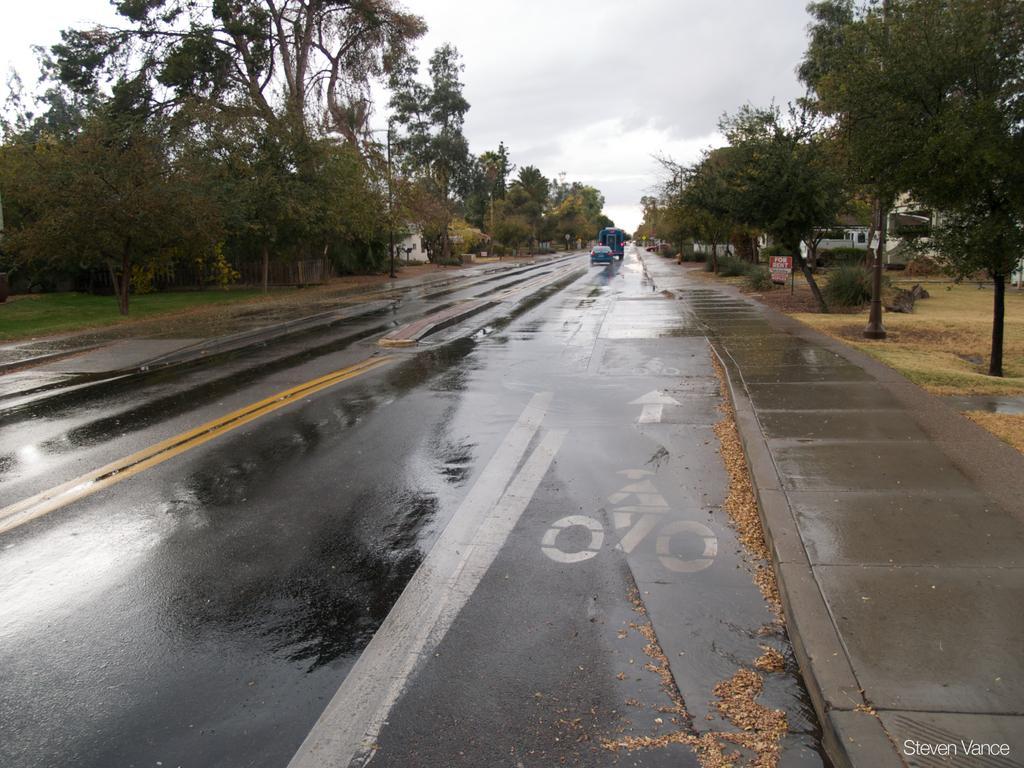Can you describe this image briefly? This image consists of a car and a truck on the road. On the left and right, there are trees. At the top, there are clouds in the sky. 